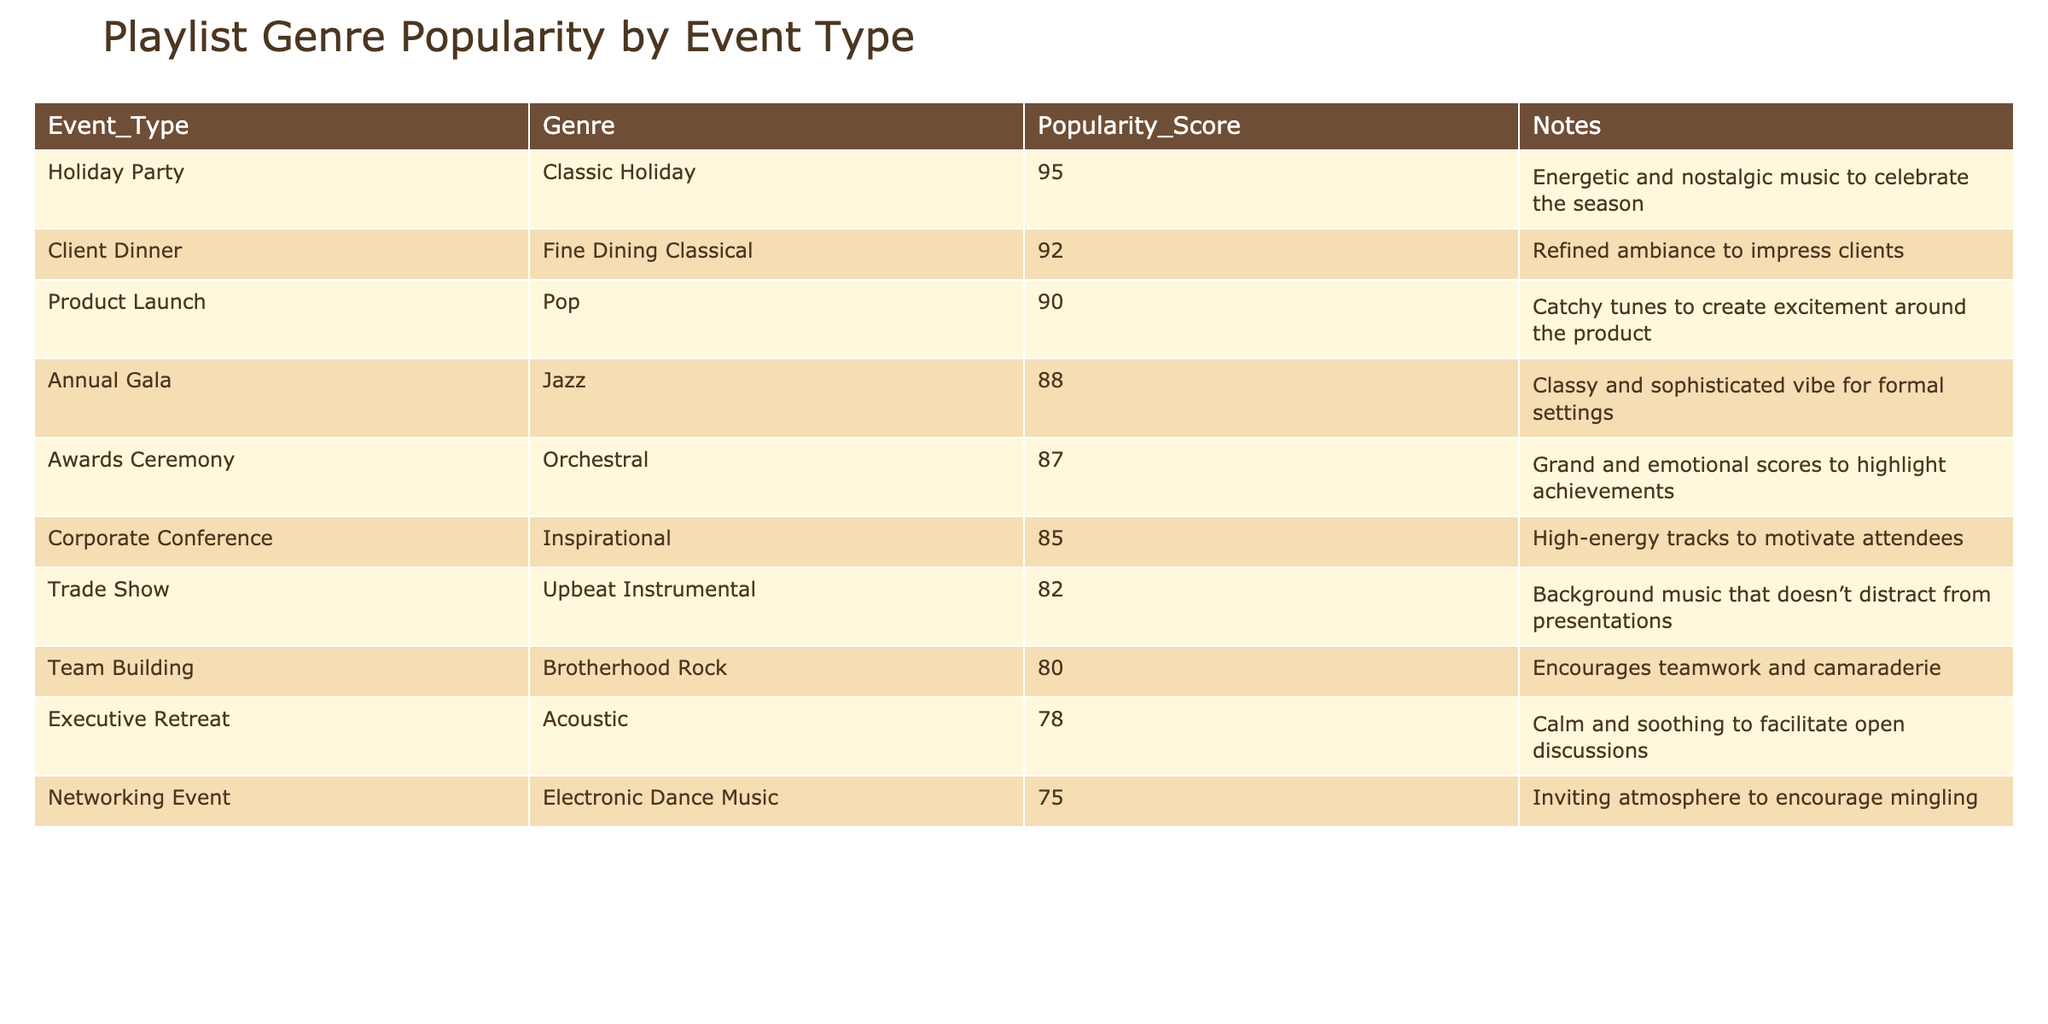What is the most popular genre for a Product Launch event? In the table, under the Product Launch event type, the genre listed is Pop, which has a Popularity Score of 90, making it the most popular for this event.
Answer: Pop Which event type has the highest Popularity Score overall? The Holiday Party event has the highest Popularity Score at 95, as seen in the table.
Answer: Holiday Party What is the average Popularity Score of genres used for networking events? There is one networking event genre listed, which is Electronic Dance Music with a Popularity Score of 75. Since there's only one event, the average is also 75.
Answer: 75 Is there any genre associated with client dinners that has a score above 90? The table shows the Client Dinner's genre is Fine Dining Classical, which has a Popularity Score of 92, confirming that it does have a score above 90.
Answer: Yes How many genres have a Popularity Score higher than 85? The genres with scores above 85 are Inspirational (85), Pop (90), Classic Holiday (95), Jazz (88), and Fine Dining Classical (92). That makes a total of five genres.
Answer: 5 Which genre is least popular for an Executive Retreat? For the Executive Retreat event, the genre listed is Acoustic with a Popularity Score of 78, making it the least popular for that event type.
Answer: Acoustic If we consider only the events with a score greater than 80, what is their average Popularity Score? The events with scores above 80 are Inspirational (85), Pop (90), Classic Holiday (95), Jazz (88), Trade Show (82), and Orchestral (87). Adding these scores together gives 85 + 90 + 95 + 88 + 82 + 87 = 527. Dividing by 6 (the number of events) gives an average of 87.833, which can be rounded to 88.
Answer: 88 Which genre is associated with the highest emotional score during an Awards Ceremony? The genre for the Awards Ceremony is Orchestral, and it has a Popularity Score of 87. This indicates it is highly emotional in context for the event.
Answer: Orchestral Are there any genres used in Team Building events that score below 80? The genre for Team Building is Brotherhood Rock which has a Popularity Score of 80. Since it is not below 80, the answer is no, there are no genres scoring below.
Answer: No What genre scored the lowest in the table for all event types? The genre with the lowest score in the provided table is Acoustic for the Executive Retreat, which has a score of 78.
Answer: Acoustic 